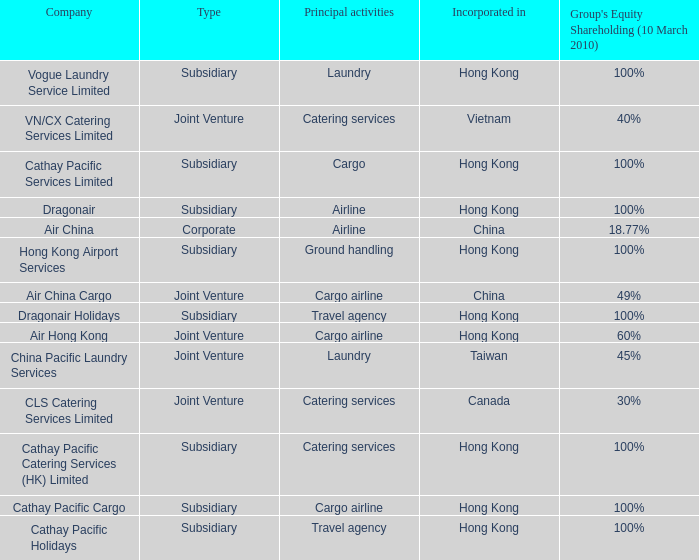Which  company's type is joint venture, and has principle activities listed as Cargo Airline and an incorporation of China? Air China Cargo. 